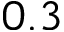Convert formula to latex. <formula><loc_0><loc_0><loc_500><loc_500>0 . 3</formula> 